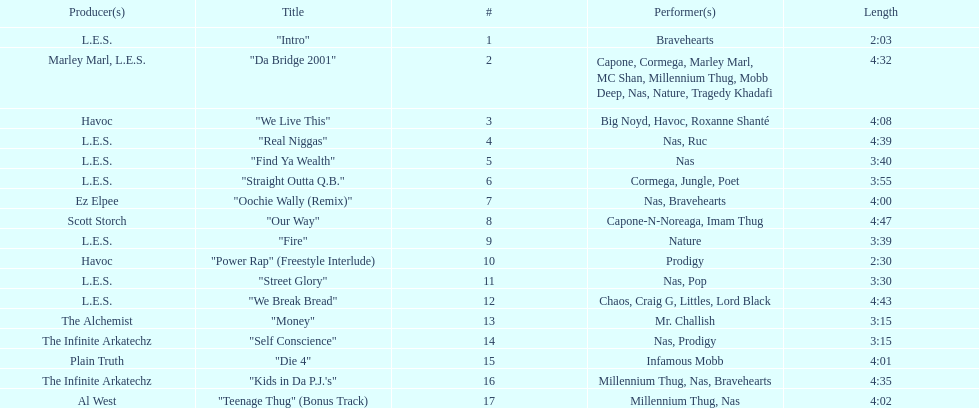Help me parse the entirety of this table. {'header': ['Producer(s)', 'Title', '#', 'Performer(s)', 'Length'], 'rows': [['L.E.S.', '"Intro"', '1', 'Bravehearts', '2:03'], ['Marley Marl, L.E.S.', '"Da Bridge 2001"', '2', 'Capone, Cormega, Marley Marl, MC Shan, Millennium Thug, Mobb Deep, Nas, Nature, Tragedy Khadafi', '4:32'], ['Havoc', '"We Live This"', '3', 'Big Noyd, Havoc, Roxanne Shanté', '4:08'], ['L.E.S.', '"Real Niggas"', '4', 'Nas, Ruc', '4:39'], ['L.E.S.', '"Find Ya Wealth"', '5', 'Nas', '3:40'], ['L.E.S.', '"Straight Outta Q.B."', '6', 'Cormega, Jungle, Poet', '3:55'], ['Ez Elpee', '"Oochie Wally (Remix)"', '7', 'Nas, Bravehearts', '4:00'], ['Scott Storch', '"Our Way"', '8', 'Capone-N-Noreaga, Imam Thug', '4:47'], ['L.E.S.', '"Fire"', '9', 'Nature', '3:39'], ['Havoc', '"Power Rap" (Freestyle Interlude)', '10', 'Prodigy', '2:30'], ['L.E.S.', '"Street Glory"', '11', 'Nas, Pop', '3:30'], ['L.E.S.', '"We Break Bread"', '12', 'Chaos, Craig G, Littles, Lord Black', '4:43'], ['The Alchemist', '"Money"', '13', 'Mr. Challish', '3:15'], ['The Infinite Arkatechz', '"Self Conscience"', '14', 'Nas, Prodigy', '3:15'], ['Plain Truth', '"Die 4"', '15', 'Infamous Mobb', '4:01'], ['The Infinite Arkatechz', '"Kids in Da P.J.\'s"', '16', 'Millennium Thug, Nas, Bravehearts', '4:35'], ['Al West', '"Teenage Thug" (Bonus Track)', '17', 'Millennium Thug, Nas', '4:02']]} How long os the longest track on the album? 4:47. 